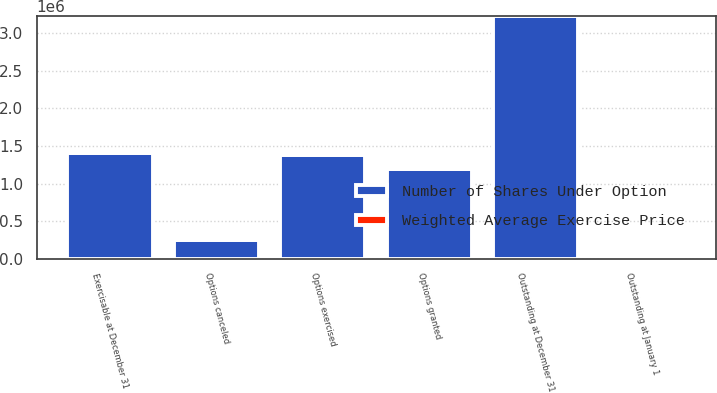<chart> <loc_0><loc_0><loc_500><loc_500><stacked_bar_chart><ecel><fcel>Outstanding at January 1<fcel>Options granted<fcel>Options exercised<fcel>Options canceled<fcel>Outstanding at December 31<fcel>Exercisable at December 31<nl><fcel>Number of Shares Under Option<fcel>53.44<fcel>1.20096e+06<fcel>1.38602e+06<fcel>245056<fcel>3.23168e+06<fcel>1.41373e+06<nl><fcel>Weighted Average Exercise Price<fcel>16.2<fcel>53.44<fcel>15.92<fcel>32.47<fcel>28.93<fcel>19.27<nl></chart> 